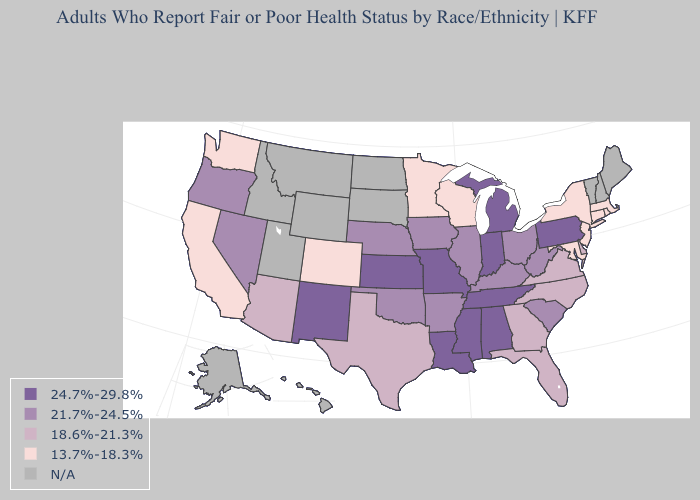Which states have the lowest value in the MidWest?
Concise answer only. Minnesota, Wisconsin. Among the states that border Wisconsin , which have the lowest value?
Quick response, please. Minnesota. What is the lowest value in the USA?
Be succinct. 13.7%-18.3%. Which states have the lowest value in the West?
Keep it brief. California, Colorado, Washington. What is the value of Oklahoma?
Answer briefly. 21.7%-24.5%. What is the lowest value in the Northeast?
Quick response, please. 13.7%-18.3%. What is the highest value in the West ?
Keep it brief. 24.7%-29.8%. Name the states that have a value in the range 13.7%-18.3%?
Be succinct. California, Colorado, Connecticut, Maryland, Massachusetts, Minnesota, New Jersey, New York, Rhode Island, Washington, Wisconsin. What is the value of Indiana?
Quick response, please. 24.7%-29.8%. Does Wisconsin have the highest value in the MidWest?
Answer briefly. No. Name the states that have a value in the range 13.7%-18.3%?
Concise answer only. California, Colorado, Connecticut, Maryland, Massachusetts, Minnesota, New Jersey, New York, Rhode Island, Washington, Wisconsin. What is the value of Maryland?
Keep it brief. 13.7%-18.3%. Which states have the lowest value in the USA?
Answer briefly. California, Colorado, Connecticut, Maryland, Massachusetts, Minnesota, New Jersey, New York, Rhode Island, Washington, Wisconsin. Which states have the lowest value in the MidWest?
Concise answer only. Minnesota, Wisconsin. Does Rhode Island have the lowest value in the USA?
Quick response, please. Yes. 